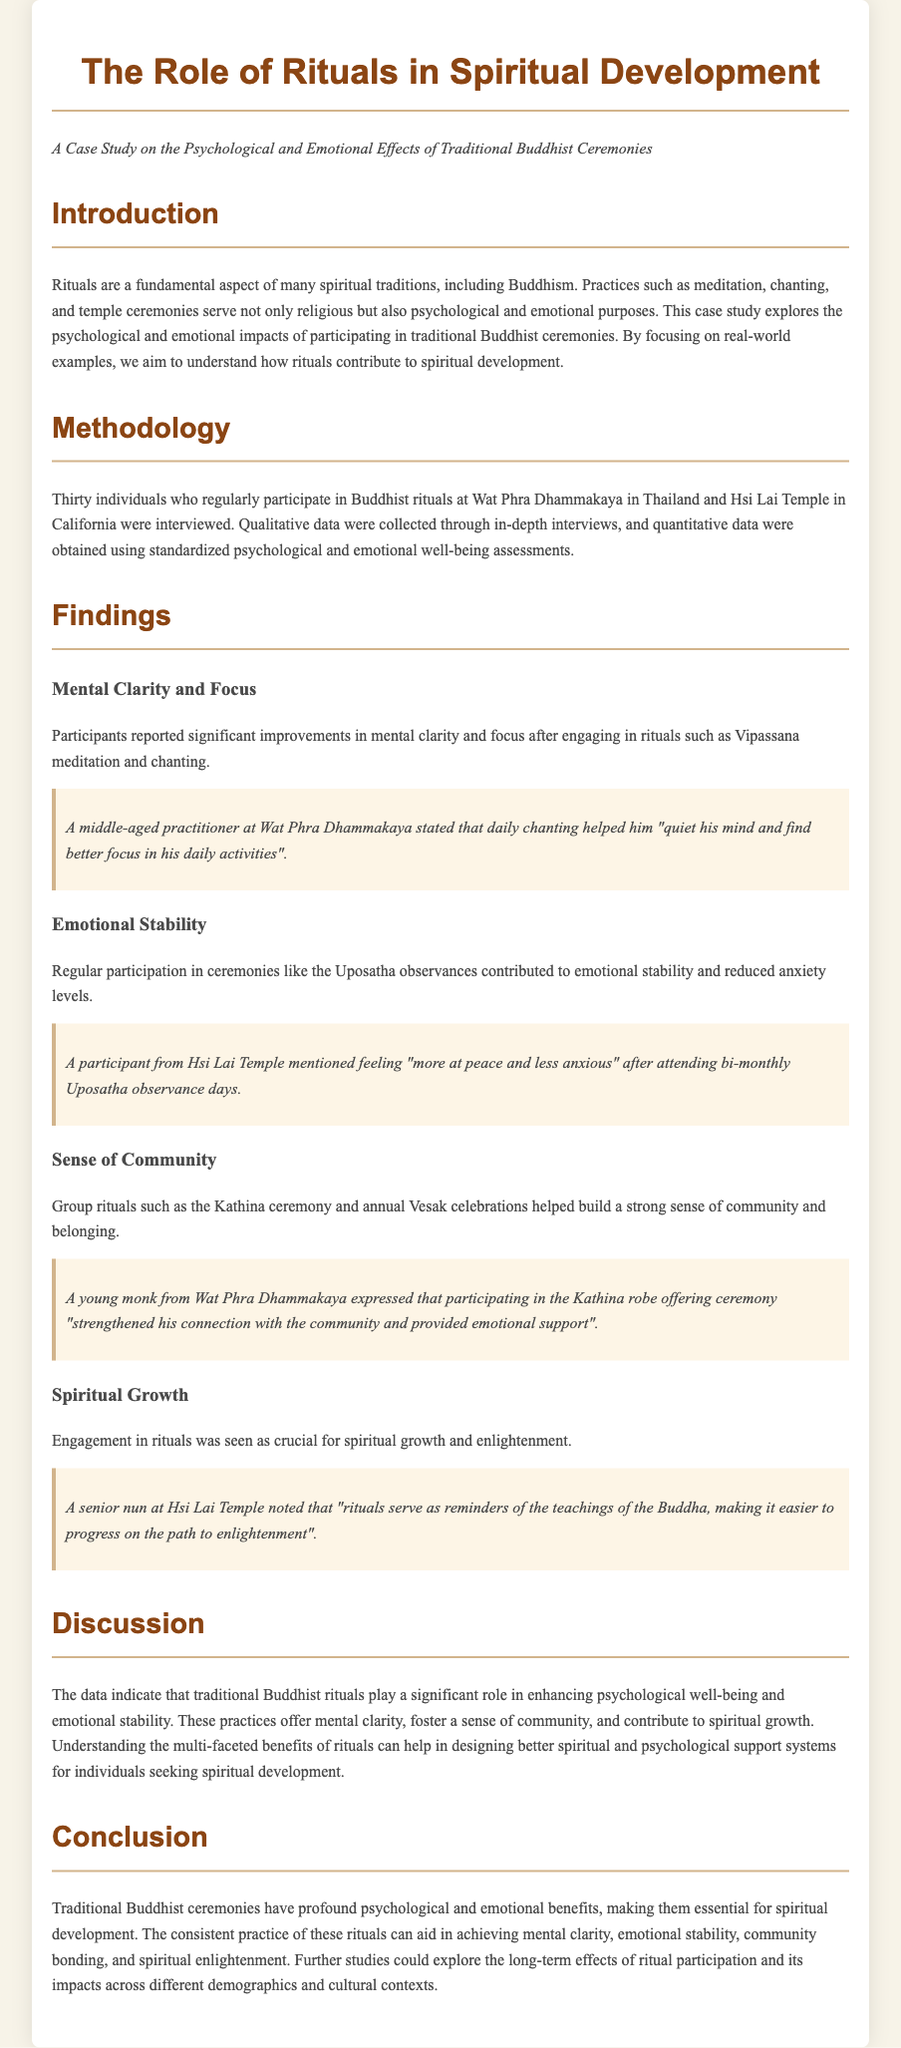What is the title of the case study? The title is stated in the header of the document, which outlines the focus on the role of rituals in spiritual development.
Answer: The Role of Rituals in Spiritual Development How many individuals were interviewed for the study? The document specifies that thirty individuals were interviewed as part of the research methodology.
Answer: Thirty What is one ritual mentioned that contributes to emotional stability? The document lists Uposatha observances as a ceremony that helps with emotional stability.
Answer: Uposatha observances Which temple in California was involved in the study? The document explicitly names Hsi Lai Temple as one of the institutions participating in the research.
Answer: Hsi Lai Temple What psychological benefit is associated with participating in Vipassana meditation? Participants reported significant improvements in mental clarity and focus, as noted in the findings section.
Answer: Mental clarity and focus What did a senior nun at Hsi Lai Temple say about rituals? The nun remarked on the importance of rituals in reminding practitioners of Buddha's teachings.
Answer: Reminders of the teachings of the Buddha What type of data was collected through in-depth interviews? The methodology describes qualitative data collection through interviews with participants.
Answer: Qualitative data What is one key discussion point highlighted in the case study? The discussion emphasizes the multi-faceted benefits of rituals for psychological well-being and emotional stability.
Answer: Multi-faceted benefits of rituals What does the conclusion suggest could be explored in further studies? The conclusion suggests that further studies could investigate the long-term effects of ritual participation.
Answer: Long-term effects of ritual participation 